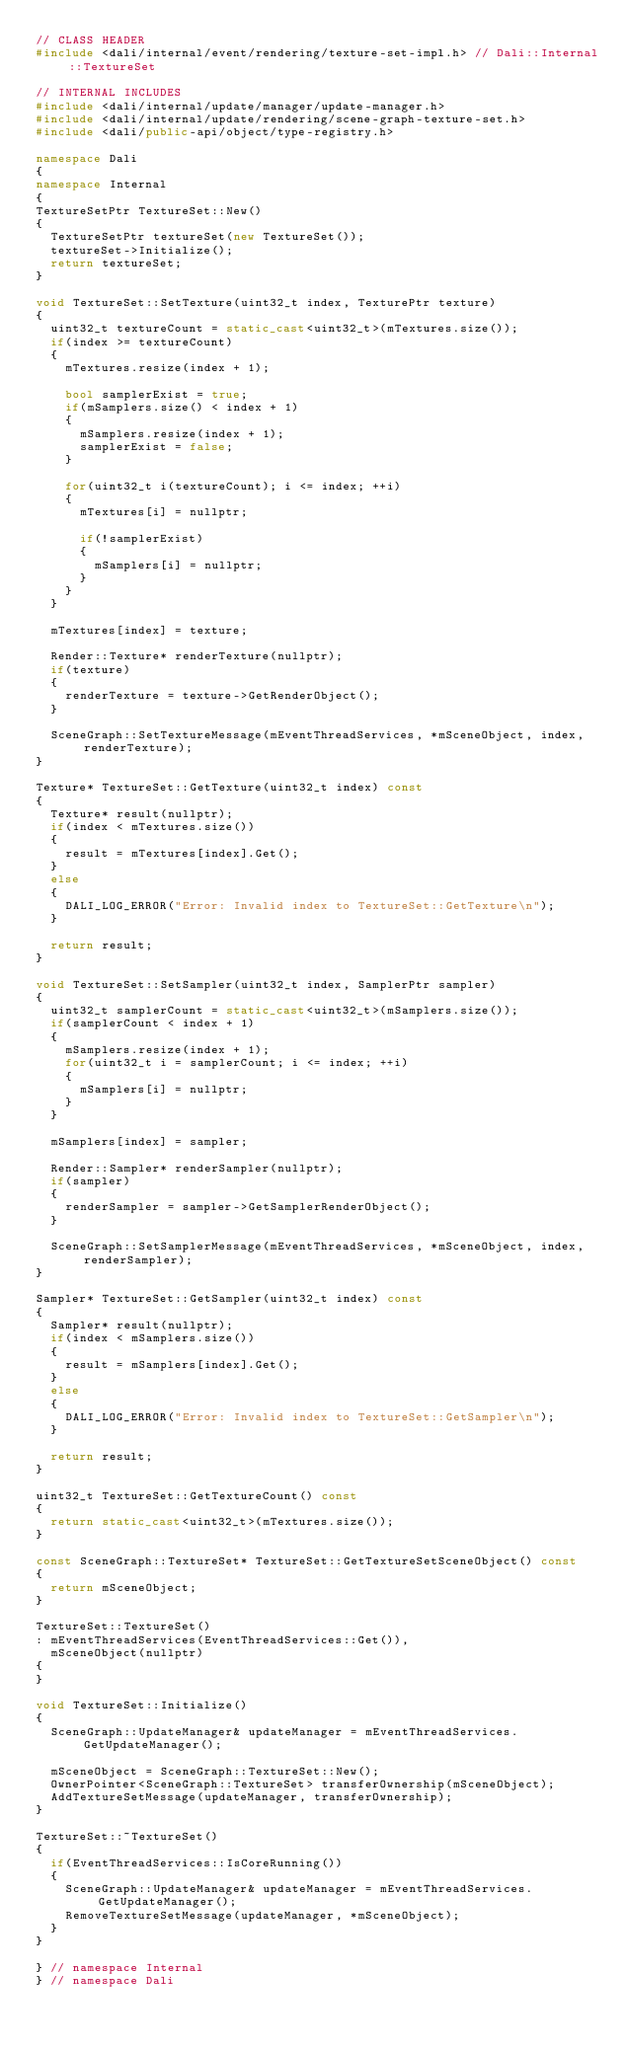Convert code to text. <code><loc_0><loc_0><loc_500><loc_500><_C++_>// CLASS HEADER
#include <dali/internal/event/rendering/texture-set-impl.h> // Dali::Internal::TextureSet

// INTERNAL INCLUDES
#include <dali/internal/update/manager/update-manager.h>
#include <dali/internal/update/rendering/scene-graph-texture-set.h>
#include <dali/public-api/object/type-registry.h>

namespace Dali
{
namespace Internal
{
TextureSetPtr TextureSet::New()
{
  TextureSetPtr textureSet(new TextureSet());
  textureSet->Initialize();
  return textureSet;
}

void TextureSet::SetTexture(uint32_t index, TexturePtr texture)
{
  uint32_t textureCount = static_cast<uint32_t>(mTextures.size());
  if(index >= textureCount)
  {
    mTextures.resize(index + 1);

    bool samplerExist = true;
    if(mSamplers.size() < index + 1)
    {
      mSamplers.resize(index + 1);
      samplerExist = false;
    }

    for(uint32_t i(textureCount); i <= index; ++i)
    {
      mTextures[i] = nullptr;

      if(!samplerExist)
      {
        mSamplers[i] = nullptr;
      }
    }
  }

  mTextures[index] = texture;

  Render::Texture* renderTexture(nullptr);
  if(texture)
  {
    renderTexture = texture->GetRenderObject();
  }

  SceneGraph::SetTextureMessage(mEventThreadServices, *mSceneObject, index, renderTexture);
}

Texture* TextureSet::GetTexture(uint32_t index) const
{
  Texture* result(nullptr);
  if(index < mTextures.size())
  {
    result = mTextures[index].Get();
  }
  else
  {
    DALI_LOG_ERROR("Error: Invalid index to TextureSet::GetTexture\n");
  }

  return result;
}

void TextureSet::SetSampler(uint32_t index, SamplerPtr sampler)
{
  uint32_t samplerCount = static_cast<uint32_t>(mSamplers.size());
  if(samplerCount < index + 1)
  {
    mSamplers.resize(index + 1);
    for(uint32_t i = samplerCount; i <= index; ++i)
    {
      mSamplers[i] = nullptr;
    }
  }

  mSamplers[index] = sampler;

  Render::Sampler* renderSampler(nullptr);
  if(sampler)
  {
    renderSampler = sampler->GetSamplerRenderObject();
  }

  SceneGraph::SetSamplerMessage(mEventThreadServices, *mSceneObject, index, renderSampler);
}

Sampler* TextureSet::GetSampler(uint32_t index) const
{
  Sampler* result(nullptr);
  if(index < mSamplers.size())
  {
    result = mSamplers[index].Get();
  }
  else
  {
    DALI_LOG_ERROR("Error: Invalid index to TextureSet::GetSampler\n");
  }

  return result;
}

uint32_t TextureSet::GetTextureCount() const
{
  return static_cast<uint32_t>(mTextures.size());
}

const SceneGraph::TextureSet* TextureSet::GetTextureSetSceneObject() const
{
  return mSceneObject;
}

TextureSet::TextureSet()
: mEventThreadServices(EventThreadServices::Get()),
  mSceneObject(nullptr)
{
}

void TextureSet::Initialize()
{
  SceneGraph::UpdateManager& updateManager = mEventThreadServices.GetUpdateManager();

  mSceneObject = SceneGraph::TextureSet::New();
  OwnerPointer<SceneGraph::TextureSet> transferOwnership(mSceneObject);
  AddTextureSetMessage(updateManager, transferOwnership);
}

TextureSet::~TextureSet()
{
  if(EventThreadServices::IsCoreRunning())
  {
    SceneGraph::UpdateManager& updateManager = mEventThreadServices.GetUpdateManager();
    RemoveTextureSetMessage(updateManager, *mSceneObject);
  }
}

} // namespace Internal
} // namespace Dali
</code> 